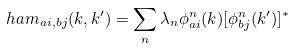<formula> <loc_0><loc_0><loc_500><loc_500>\ h a m _ { a i , b j } ( k , k ^ { \prime } ) = \sum _ { n } \lambda _ { n } \phi ^ { n } _ { a i } ( k ) [ \phi ^ { n } _ { b j } ( k ^ { \prime } ) ] ^ { * }</formula> 